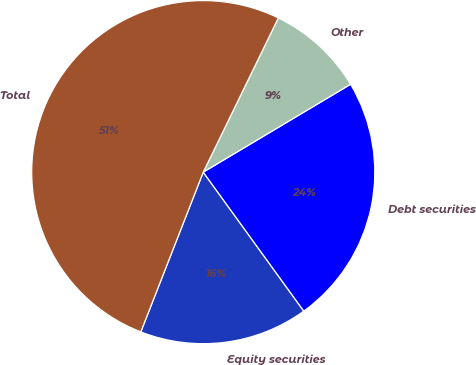Convert chart. <chart><loc_0><loc_0><loc_500><loc_500><pie_chart><fcel>Equity securities<fcel>Debt securities<fcel>Other<fcel>Total<nl><fcel>15.9%<fcel>23.59%<fcel>9.23%<fcel>51.28%<nl></chart> 